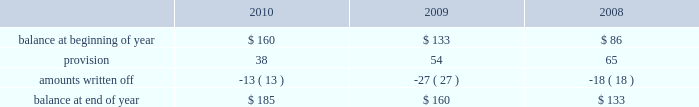Allowance for doubtful accounts is as follows: .
Discontinued operations during the fourth quarter of 2009 , schlumberger recorded a net $ 22 million charge related to the resolution of a customs assessment pertaining to its former offshore contract drilling business , as well as the resolution of certain contingencies associated with other previously disposed of businesses .
This amount is included in income ( loss ) from discontinued operations in the consolidated statement of income .
During the first quarter of 2008 , schlumberger recorded a gain of $ 38 million related to the resolution of a contingency associated with a previously disposed of business .
This gain is included in income ( loss ) from discon- tinued operations in the consolidated statement of income .
Part ii , item 8 .
In 2010 , what percentage of allowance for doubtful accounts were written off? 
Computations: (13 / 160)
Answer: 0.08125. 